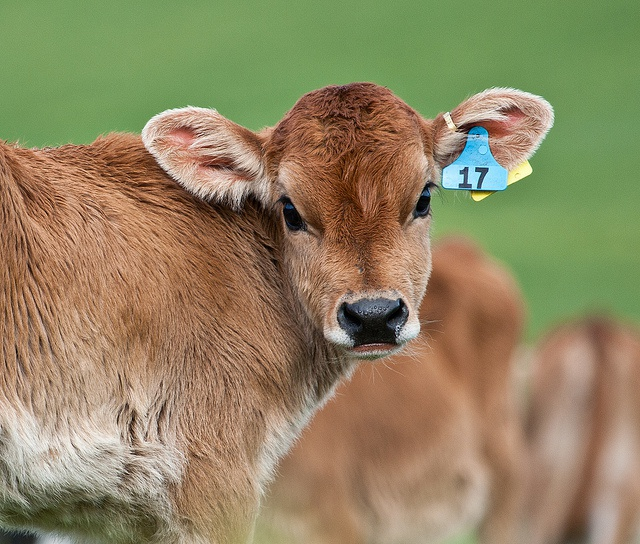Describe the objects in this image and their specific colors. I can see cow in olive, gray, tan, and maroon tones and cow in olive, gray, and tan tones in this image. 